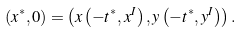Convert formula to latex. <formula><loc_0><loc_0><loc_500><loc_500>( x ^ { * } , 0 ) = \left ( x \left ( - t ^ { * } , x ^ { I } \right ) , y \left ( - t ^ { * } , y ^ { I } \right ) \right ) .</formula> 